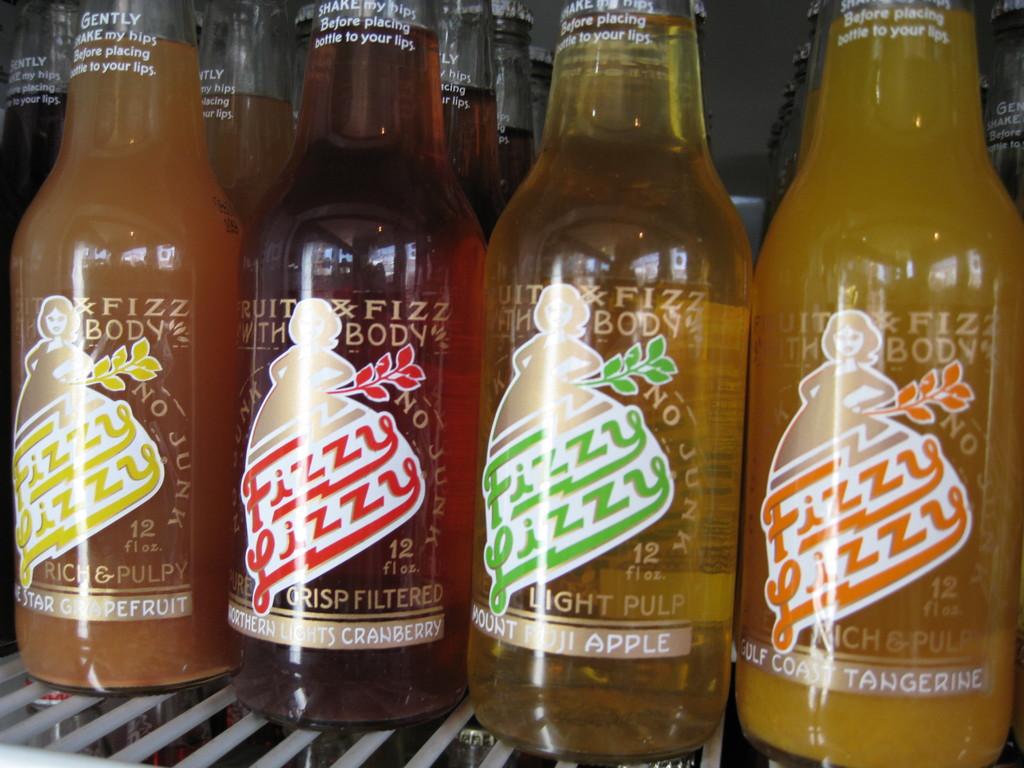Which one has light pulp?
Give a very brief answer. Apple. What is the company's name?
Provide a short and direct response. Fizzy lizzy. 